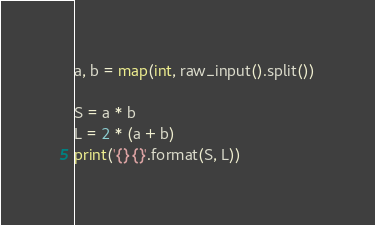<code> <loc_0><loc_0><loc_500><loc_500><_Python_>a, b = map(int, raw_input().split())

S = a * b
L = 2 * (a + b)
print('{} {}'.format(S, L))</code> 